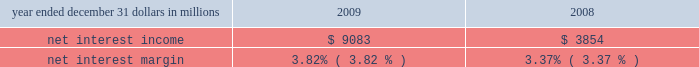Consolidated income statement review net income for 2009 was $ 2.4 billion and for 2008 was $ 914 million .
Amounts for 2009 include operating results of national city and the fourth quarter impact of a $ 687 million after-tax gain related to blackrock 2019s acquisition of bgi .
Increases in income statement comparisons to 2008 , except as noted , are primarily due to the operating results of national city .
Our consolidated income statement is presented in item 8 of this report .
Net interest income and net interest margin year ended december 31 dollars in millions 2009 2008 .
Changes in net interest income and margin result from the interaction of the volume and composition of interest-earning assets and related yields , interest-bearing liabilities and related rates paid , and noninterest-bearing sources of funding .
See statistical information 2013 analysis of year-to-year changes in net interest ( unaudited ) income and average consolidated balance sheet and net interest analysis in item 8 of this report for additional information .
Higher net interest income for 2009 compared with 2008 reflected the increase in average interest-earning assets due to national city and the improvement in the net interest margin .
The net interest margin was 3.82% ( 3.82 % ) for 2009 and 3.37% ( 3.37 % ) for 2008 .
The following factors impacted the comparison : 2022 a decrease in the rate accrued on interest-bearing liabilities of 97 basis points .
The rate accrued on interest-bearing deposits , the largest component , decreased 107 basis points .
2022 these factors were partially offset by a 45 basis point decrease in the yield on interest-earning assets .
The yield on loans , which represented the largest portion of our earning assets in 2009 , decreased 30 basis points .
2022 in addition , the impact of noninterest-bearing sources of funding decreased 7 basis points .
For comparing to the broader market , the average federal funds rate was .16% ( .16 % ) for 2009 compared with 1.94% ( 1.94 % ) for 2008 .
We expect our net interest income for 2010 will likely be modestly lower as a result of cash recoveries on purchased impaired loans in 2009 and additional run-off of higher- yielding assets , which could be mitigated by rising interest rates .
This assumes our current expectations for interest rates and economic conditions 2013 we include our current economic assumptions underlying our forward-looking statements in the cautionary statement regarding forward-looking information section of this item 7 .
Noninterest income summary noninterest income was $ 7.1 billion for 2009 and $ 2.4 billion for 2008 .
Noninterest income for 2009 included the following : 2022 the gain on blackrock/bgi transaction of $ 1.076 billion , 2022 net credit-related other-than-temporary impairments ( otti ) on debt and equity securities of $ 577 million , 2022 net gains on sales of securities of $ 550 million , 2022 gains on hedging of residential mortgage servicing rights of $ 355 million , 2022 valuation and sale income related to our commercial mortgage loans held for sale , net of hedges , of $ 107 million , 2022 gains of $ 103 million related to our blackrock ltip shares adjustment in the first quarter , and net losses on private equity and alternative investments of $ 93 million .
Noninterest income for 2008 included the following : 2022 net otti on debt and equity securities of $ 312 million , 2022 gains of $ 246 million related to our blackrock ltip shares adjustment , 2022 valuation and sale losses related to our commercial mortgage loans held for sale , net of hedges , of $ 197 million , 2022 impairment and other losses related to private equity and alternative investments of $ 180 million , 2022 income from hilliard lyons totaling $ 164 million , including the first quarter gain of $ 114 million from the sale of this business , 2022 net gains on sales of securities of $ 106 million , and 2022 a gain of $ 95 million related to the redemption of a portion of our visa class b common shares related to visa 2019s march 2008 initial public offering .
Additional analysis asset management revenue increased $ 172 million to $ 858 million in 2009 , compared with $ 686 million in 2008 .
This increase reflected improving equity markets , new business generation and a shift in assets into higher yielding equity investments during the second half of 2009 .
Assets managed totaled $ 103 billion at both december 31 , 2009 and 2008 , including the impact of national city .
The asset management group section of the business segments review section of this item 7 includes further discussion of assets under management .
Consumer services fees totaled $ 1.290 billion in 2009 compared with $ 623 million in 2008 .
Service charges on deposits totaled $ 950 million for 2009 and $ 372 million for 2008 .
Both increases were primarily driven by the impact of the national city acquisition .
Reduced consumer spending .
What was the ratio of the net interest income in 2009 to 2008? 
Computations: (9083 / 3854)
Answer: 2.35677. 